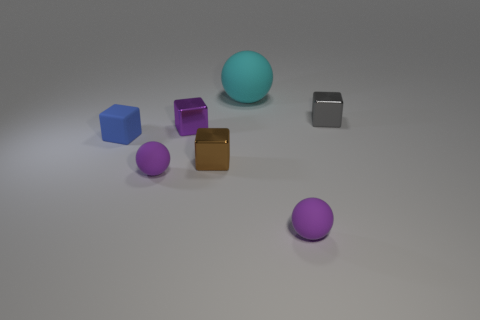Do the big rubber thing and the brown shiny object have the same shape?
Offer a very short reply. No. There is a cyan object that is the same material as the blue block; what is its size?
Offer a very short reply. Large. Are there fewer tiny brown metallic objects than big cyan cylinders?
Make the answer very short. No. What number of tiny things are brown blocks or purple shiny objects?
Your answer should be compact. 2. What number of small things are both in front of the tiny brown metallic thing and to the left of the small purple metallic object?
Keep it short and to the point. 1. Are there more big balls than tiny cyan things?
Provide a succinct answer. Yes. How many other objects are the same shape as the gray shiny thing?
Offer a very short reply. 3. What material is the tiny cube that is on the right side of the matte block and in front of the small purple metallic thing?
Offer a very short reply. Metal. How big is the brown object?
Provide a succinct answer. Small. What number of large cyan spheres are in front of the small purple rubber thing on the right side of the ball that is behind the tiny gray metal object?
Offer a very short reply. 0. 